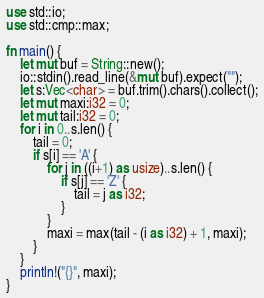<code> <loc_0><loc_0><loc_500><loc_500><_Rust_>use std::io;
use std::cmp::max;

fn main() {
	let mut buf = String::new();
	io::stdin().read_line(&mut buf).expect("");
	let s:Vec<char> = buf.trim().chars().collect();
	let mut maxi:i32 = 0;
	let mut tail:i32 = 0;
	for i in 0..s.len() {
		tail = 0;
		if s[i] == 'A' {
			for j in ((i+1) as usize)..s.len() {
				if s[j] == 'Z' {
					tail = j as i32;
				}
			}
			maxi = max(tail - (i as i32) + 1, maxi);
		}
	}
	println!("{}", maxi);
}</code> 